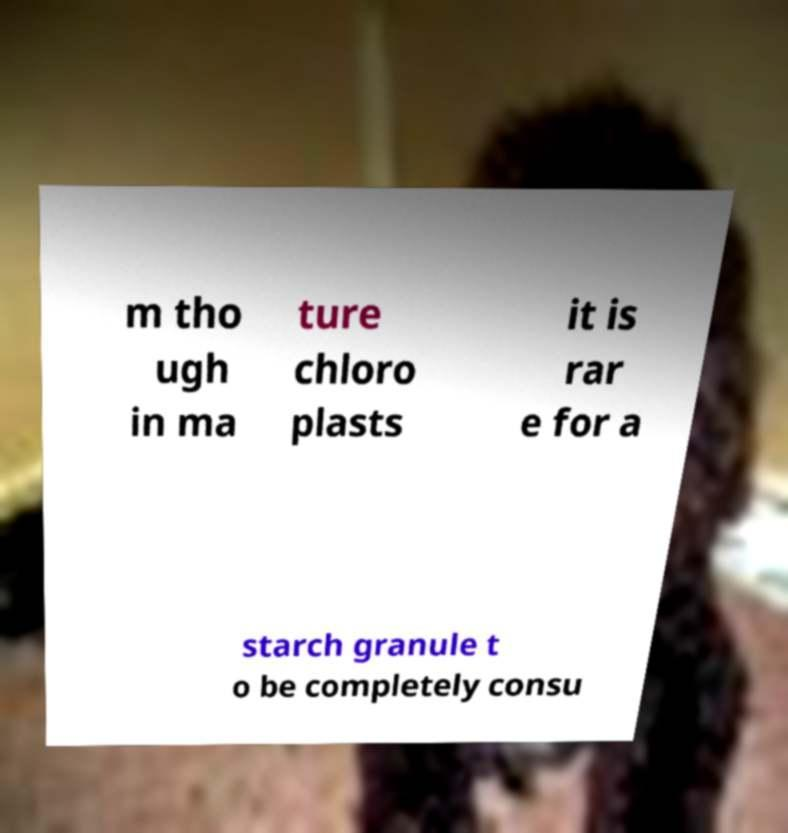There's text embedded in this image that I need extracted. Can you transcribe it verbatim? m tho ugh in ma ture chloro plasts it is rar e for a starch granule t o be completely consu 